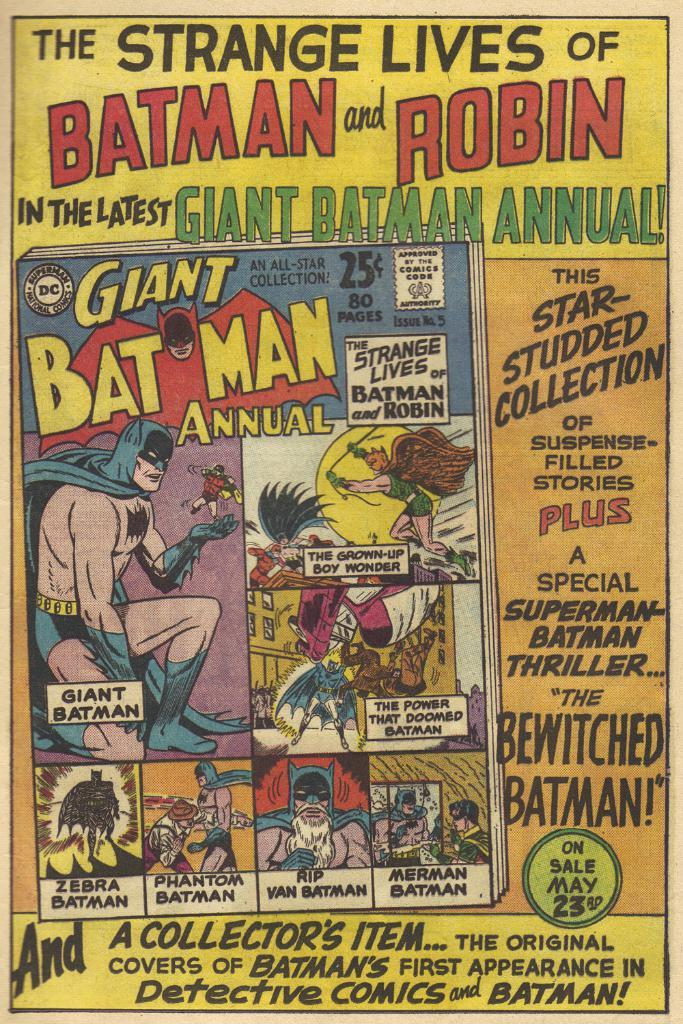Provide a one-sentence caption for the provided image. The Strange Lives of Batman and Robincomic book was a collector's item then and now. 